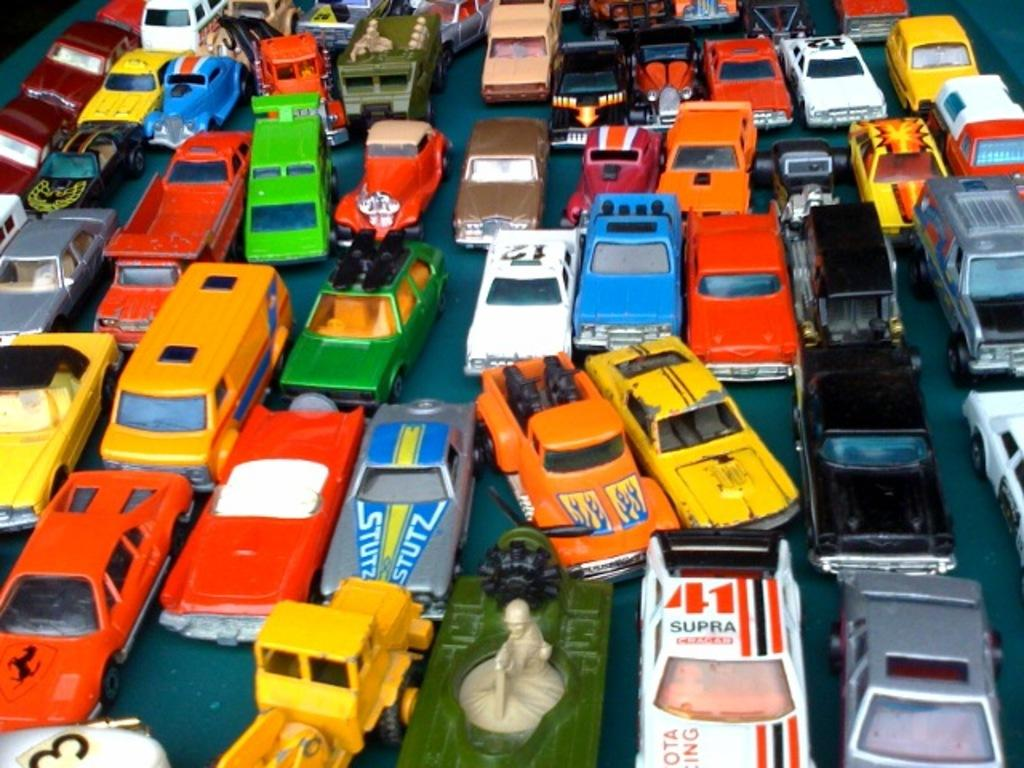Provide a one-sentence caption for the provided image. Many toy cars are shown in a group including one that says 41 Supra and another that says Stutz. 